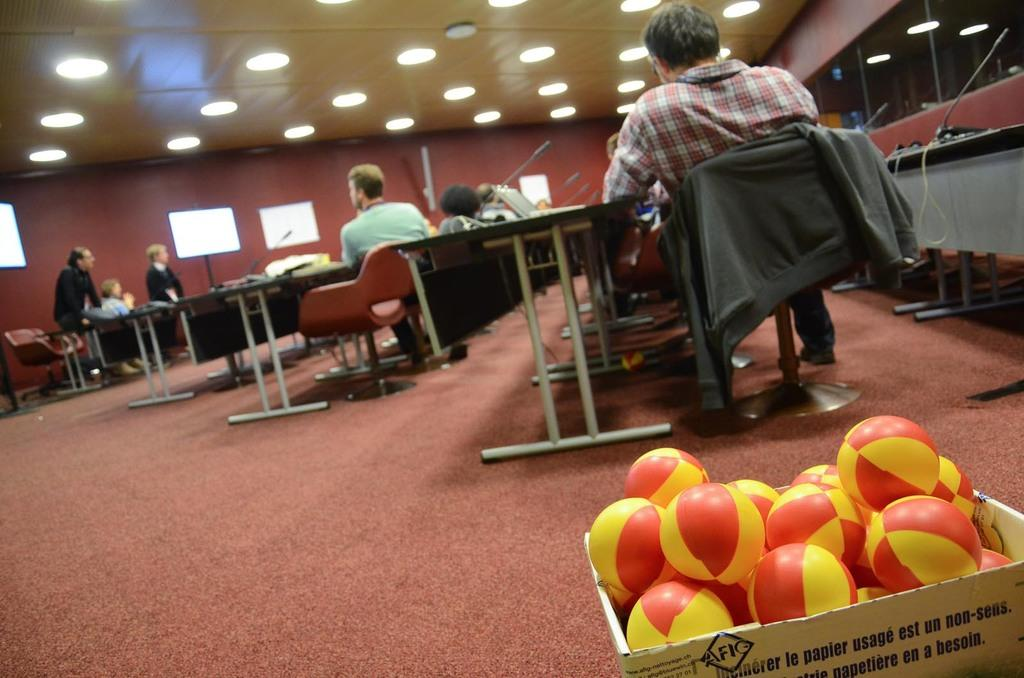What objects are in the box on the right side of the image? There are balls in a box on the right side of the image. What are the people in the image doing? The people in the image are sitting on chairs. What type of furniture is present in the image? There are tables in the image. What can be seen at the top of the image? There are lights visible at the top of the image. What is the number of wealth conditions depicted in the image? There is no reference to wealth or conditions in the image; it features balls in a box, people sitting on chairs, tables, and lights. 